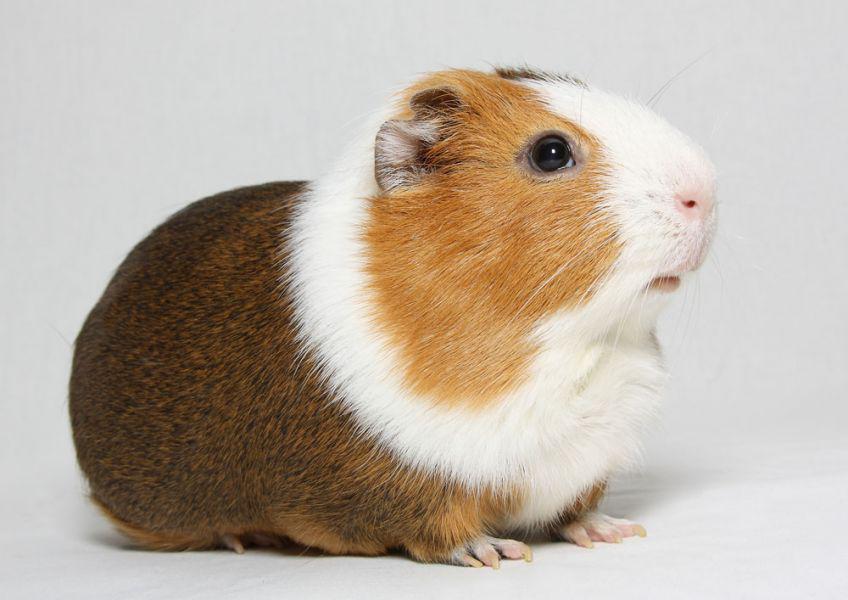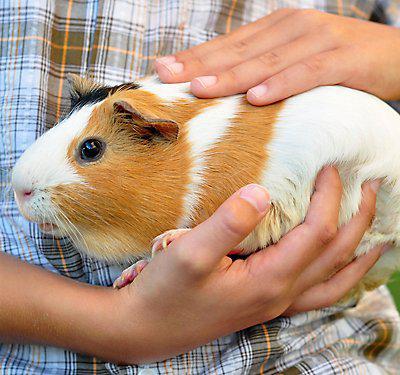The first image is the image on the left, the second image is the image on the right. Analyze the images presented: Is the assertion "The image on the left contains food." valid? Answer yes or no. No. 